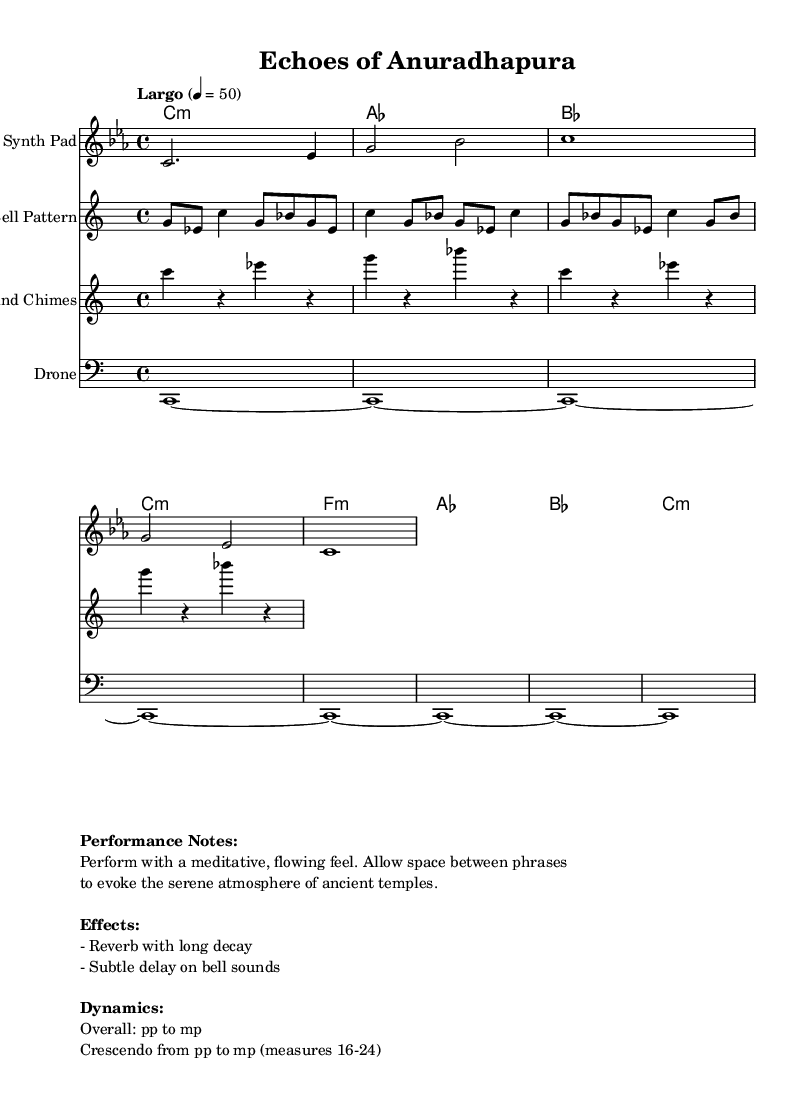What is the key signature of this music? The key signature is indicated by the absence of sharps or flats, which suggests that it is in C minor.
Answer: C minor What is the time signature of this piece? The time signature is marked at the beginning of the sheet music as 4/4, indicating four beats per measure.
Answer: 4/4 What is the tempo marking for this composition? The tempo marking specifies "Largo" with a metronome marking of quarter note equals 50, indicating a slow pace.
Answer: Largo How many measures are there in the melody section? Counting the distinct phrases, the melody section consists of four measures, each separated by a bar line.
Answer: 4 Which instruments are featured in this composition? The score lists multiple instruments including a synth pad for the melody, bell pattern, wind chimes, and a drone.
Answer: Synth Pad, Bell Pattern, Wind Chimes, Drone What dynamic markings are indicated for the overall performance? The dynamic markings show an overall dynamic from pianissimo to mezzopiano, suggesting a soft to moderately soft approach.
Answer: pp to mp What unique electronic effect is suggested for the bell sounds? The performance notes indicate the use of a "subtle delay" on the bell sounds to enhance the ambiance.
Answer: Subtle delay 